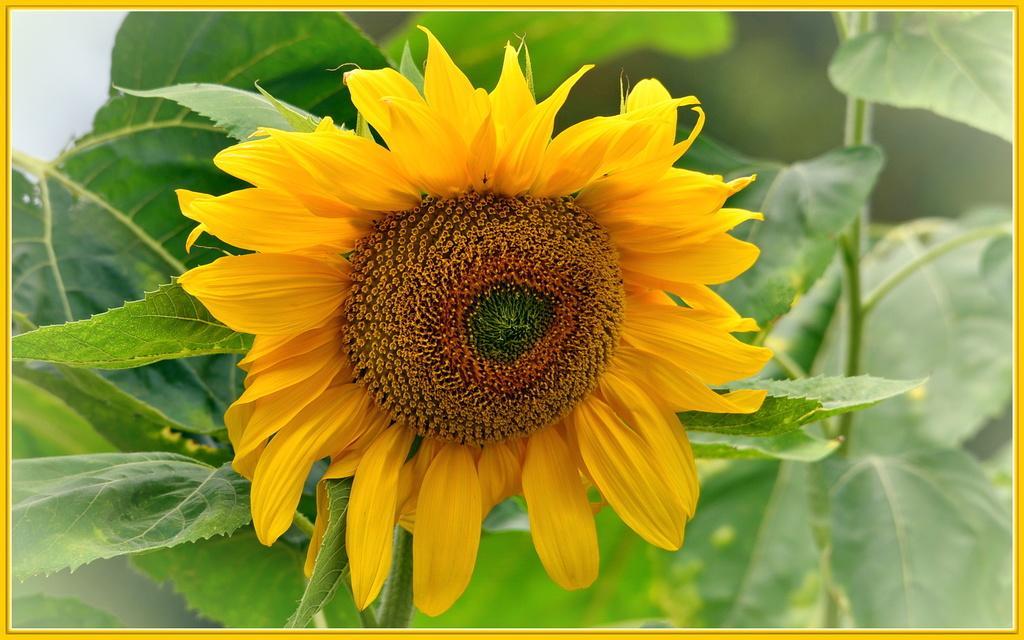How would you summarize this image in a sentence or two? In this image, I can see a sunflower with yellow petals. These are the leaves. This looks like a stem. 